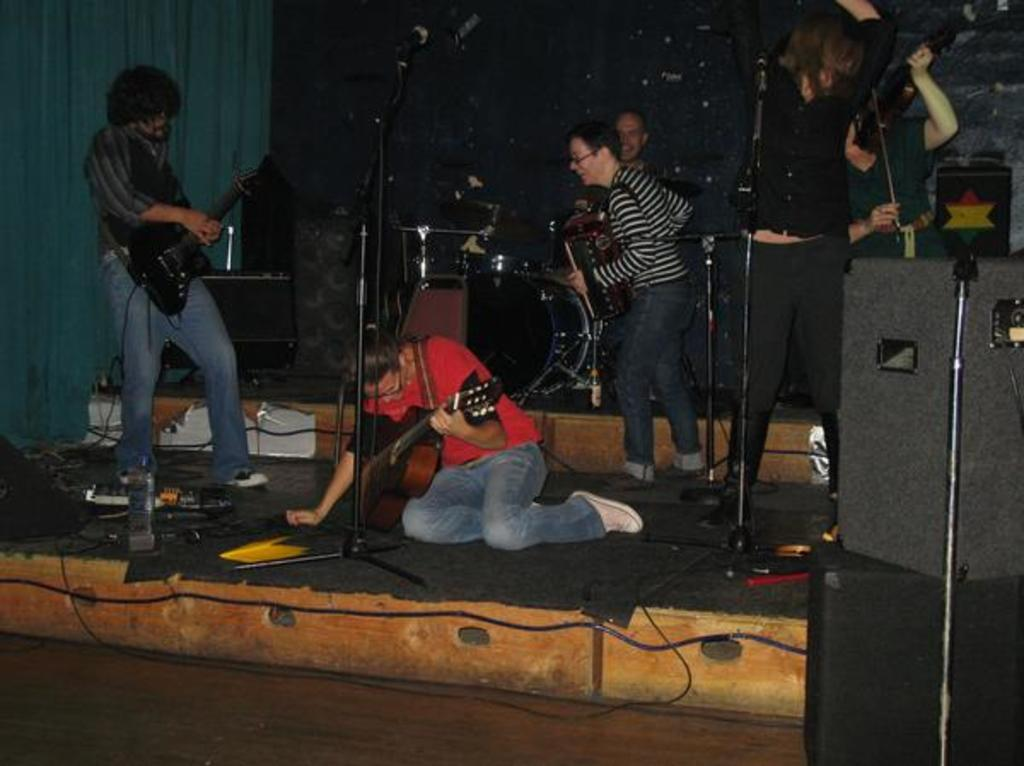What is the person in the image wearing? The person is wearing a red shirt in the image. What is the person doing in the image? The person is sitting on the ground and holding a guitar. Are there other people in the image? Yes, there are musicians around the person. What can be seen in the right corner of the image? There is a speaker in the right corner of the image. What type of polish is the person applying to the goat in the image? There is no goat or polish present in the image; the person is holding a guitar and surrounded by other musicians. 